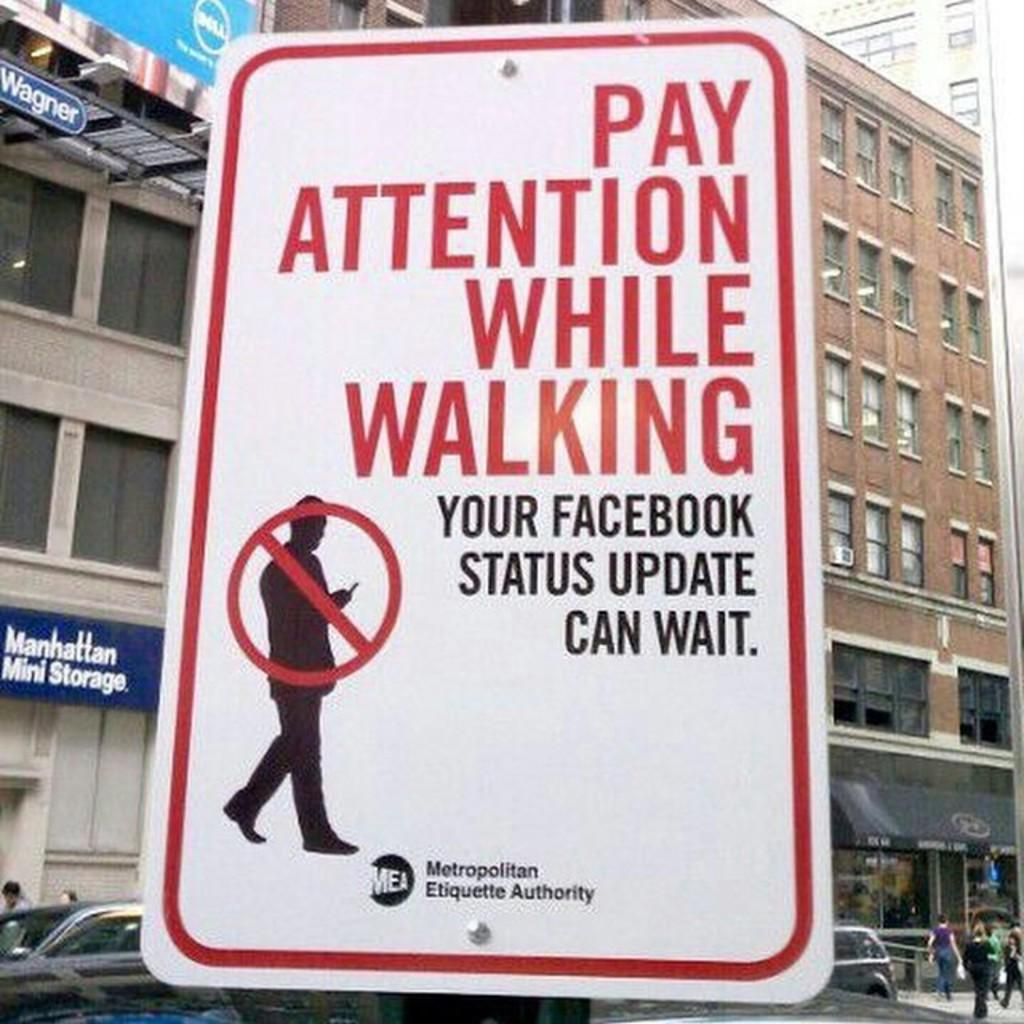Provide a one-sentence caption for the provided image. A white sign that says Pay Attention While walking in red. 